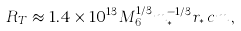<formula> <loc_0><loc_0><loc_500><loc_500>R _ { T } \approx 1 . 4 \times 1 0 ^ { 1 3 } M _ { 6 } ^ { 1 / 3 } m _ { * } ^ { - 1 / 3 } r _ { * } \, c m \, ,</formula> 